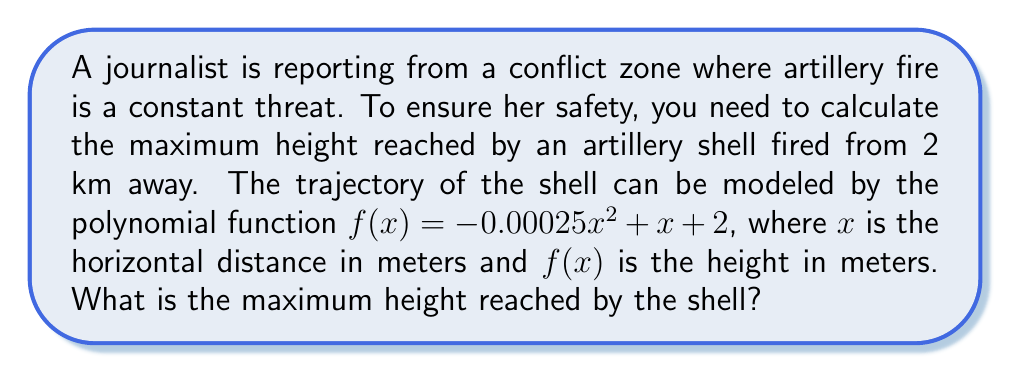Teach me how to tackle this problem. To find the maximum height of the projectile, we need to follow these steps:

1) The polynomial function given is in the form of a quadratic equation:
   $f(x) = -0.00025x^2 + x + 2$

2) For a quadratic function $f(x) = ax^2 + bx + c$, the x-coordinate of the vertex is given by $x = -\frac{b}{2a}$

3) In our case, $a = -0.00025$ and $b = 1$. Let's calculate the x-coordinate of the vertex:

   $x = -\frac{1}{2(-0.00025)} = 2000$ meters

4) This means the shell reaches its maximum height when it has traveled 2000 meters horizontally.

5) To find the maximum height, we need to substitute this x-value back into our original function:

   $f(2000) = -0.00025(2000)^2 + 2000 + 2$
            $= -0.00025(4,000,000) + 2000 + 2$
            $= -1000 + 2000 + 2$
            $= 1002$ meters

Therefore, the maximum height reached by the shell is 1002 meters.
Answer: 1002 meters 